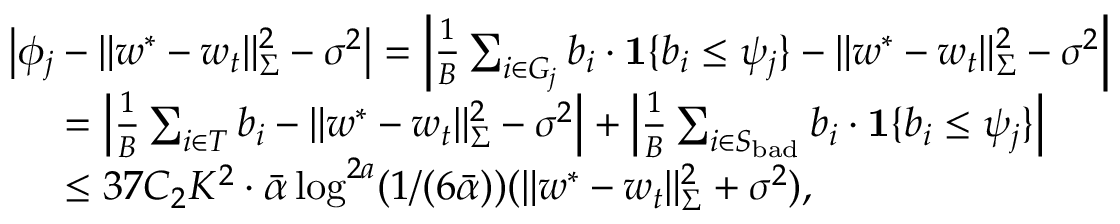<formula> <loc_0><loc_0><loc_500><loc_500>\begin{array} { r l } & { \left | \phi _ { j } - \| w ^ { * } - w _ { t } \| _ { \Sigma } ^ { 2 } - \sigma ^ { 2 } \right | = \left | \frac { 1 } { B } \sum _ { i \in G _ { j } } b _ { i } \cdot 1 \{ b _ { i } \leq \psi _ { j } \} - \| w ^ { * } - w _ { t } \| _ { \Sigma } ^ { 2 } - \sigma ^ { 2 } \right | } \\ & { \, = \left | \frac { 1 } { B } \sum _ { i \in T } b _ { i } - \| w ^ { * } - w _ { t } \| _ { \Sigma } ^ { 2 } - \sigma ^ { 2 } \right | + \left | \frac { 1 } { B } \sum _ { i \in S _ { b a d } } b _ { i } \cdot 1 \{ b _ { i } \leq \psi _ { j } \} \right | } \\ & { \, \leq 3 7 C _ { 2 } K ^ { 2 } \cdot \bar { \alpha } \log ^ { 2 a } ( 1 / ( 6 \bar { \alpha } ) ) ( \| w ^ { * } - w _ { t } \| _ { \Sigma } ^ { 2 } + \sigma ^ { 2 } ) , } \end{array}</formula> 